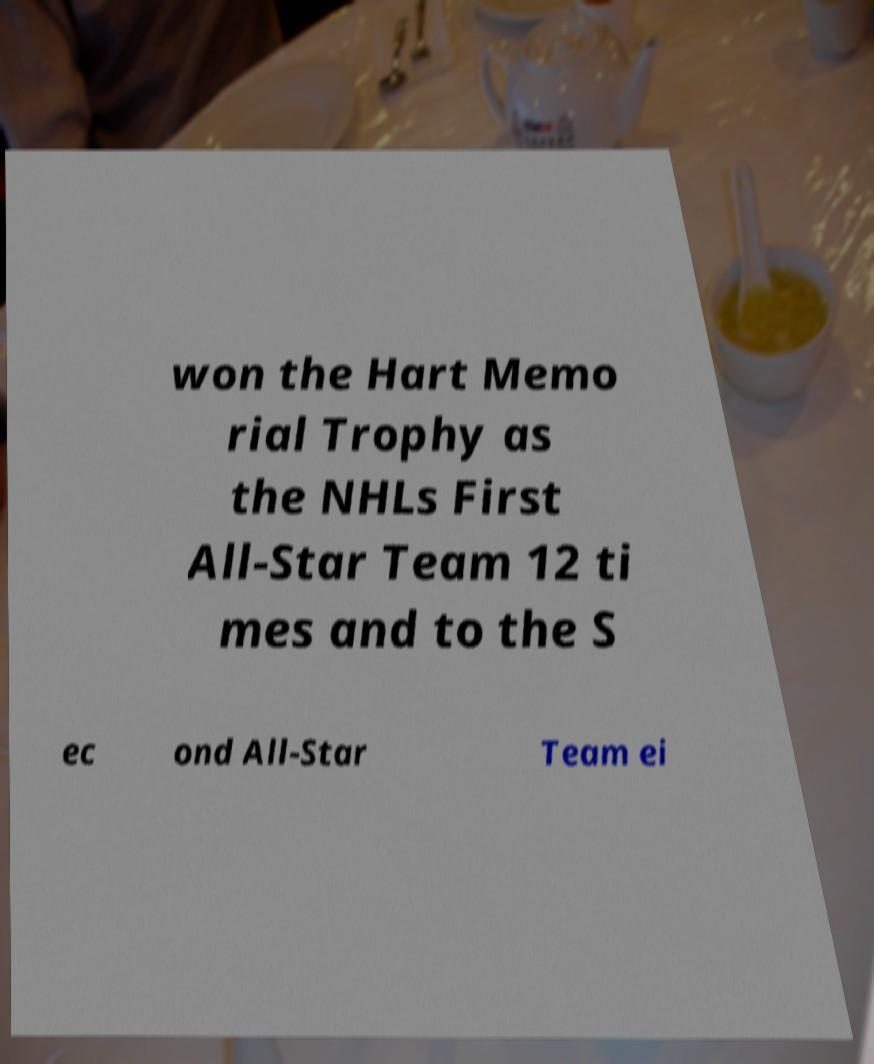Please identify and transcribe the text found in this image. won the Hart Memo rial Trophy as the NHLs First All-Star Team 12 ti mes and to the S ec ond All-Star Team ei 